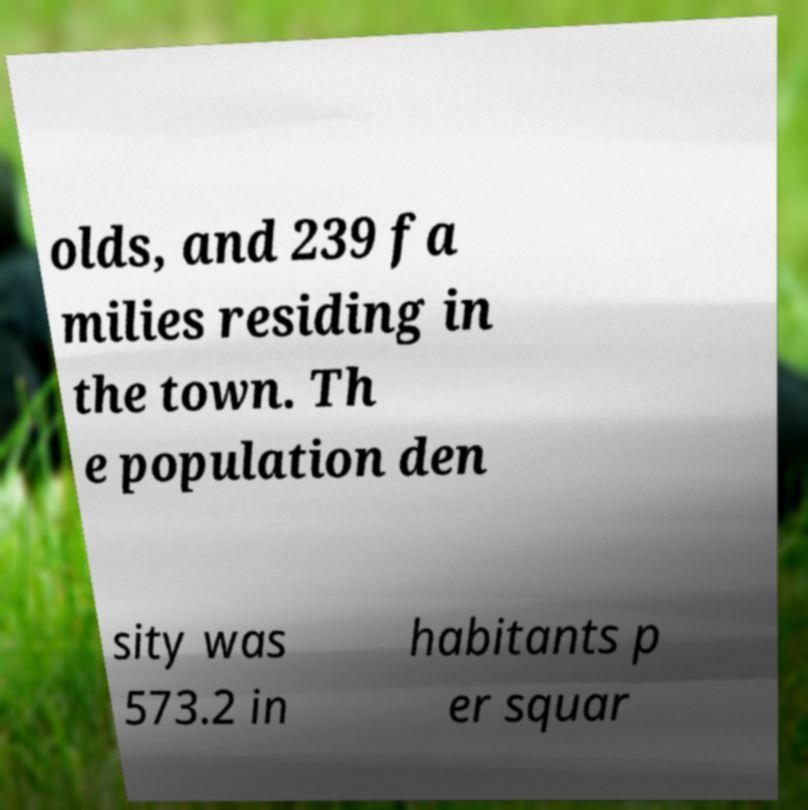Please read and relay the text visible in this image. What does it say? olds, and 239 fa milies residing in the town. Th e population den sity was 573.2 in habitants p er squar 